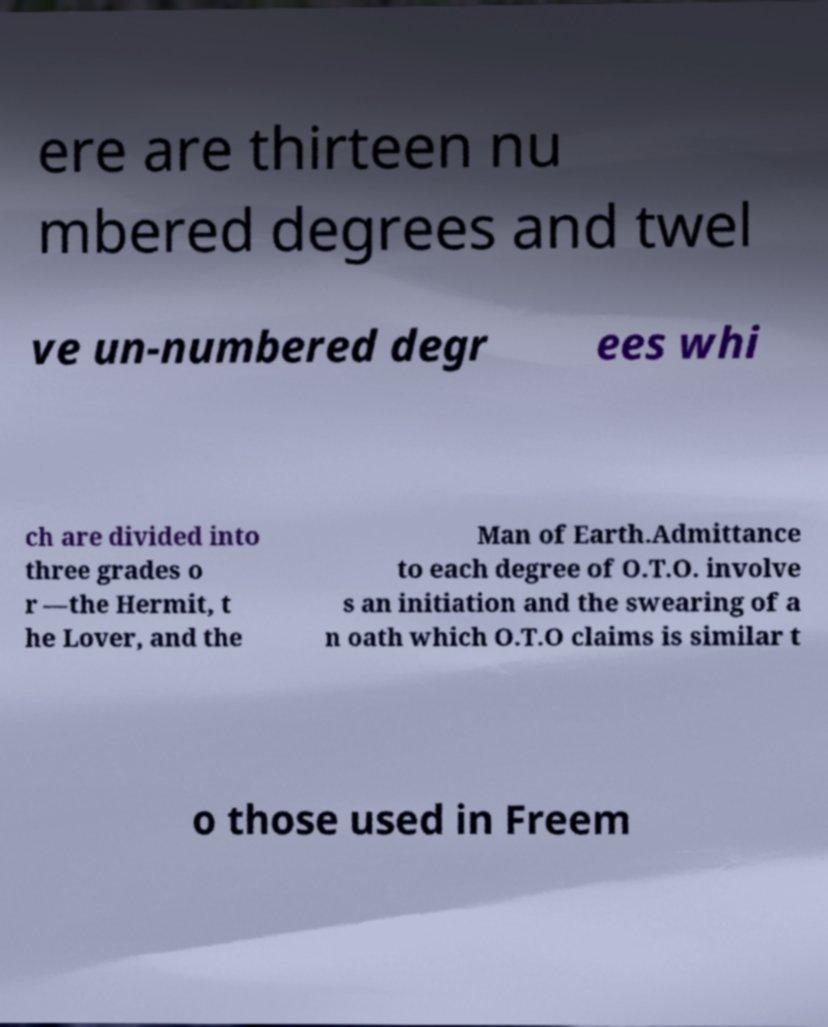For documentation purposes, I need the text within this image transcribed. Could you provide that? ere are thirteen nu mbered degrees and twel ve un-numbered degr ees whi ch are divided into three grades o r —the Hermit, t he Lover, and the Man of Earth.Admittance to each degree of O.T.O. involve s an initiation and the swearing of a n oath which O.T.O claims is similar t o those used in Freem 